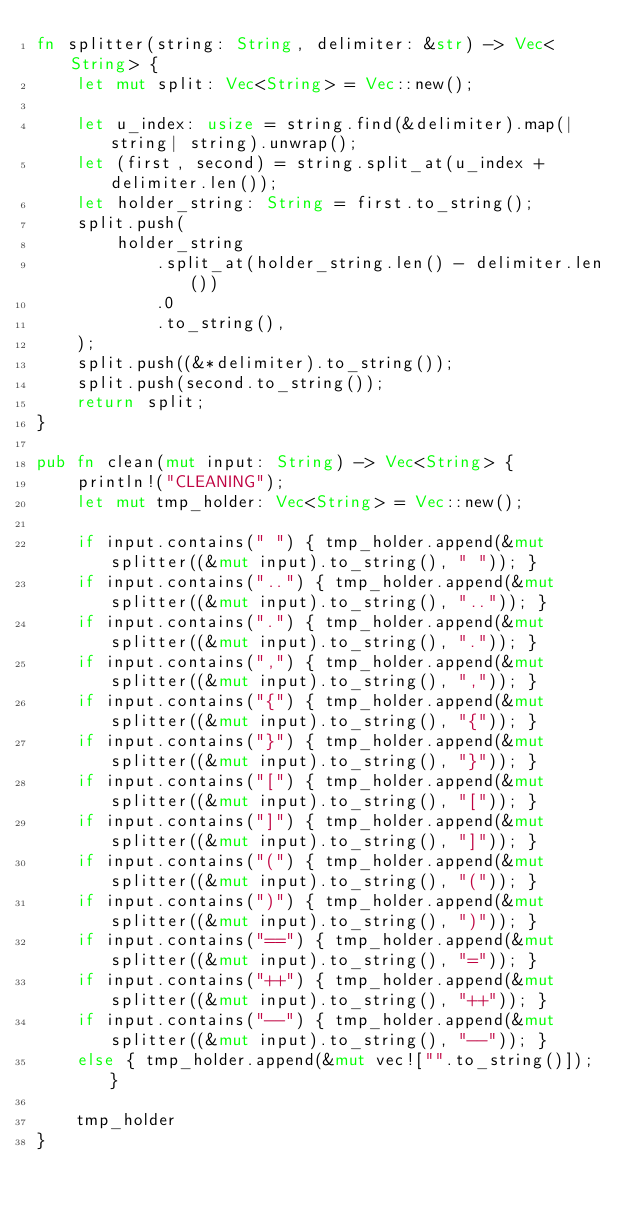Convert code to text. <code><loc_0><loc_0><loc_500><loc_500><_Rust_>fn splitter(string: String, delimiter: &str) -> Vec<String> {
    let mut split: Vec<String> = Vec::new();

    let u_index: usize = string.find(&delimiter).map(|string| string).unwrap();
    let (first, second) = string.split_at(u_index + delimiter.len());
    let holder_string: String = first.to_string();
    split.push(
        holder_string
            .split_at(holder_string.len() - delimiter.len())
            .0
            .to_string(),
    );
    split.push((&*delimiter).to_string());
    split.push(second.to_string());
    return split;
}

pub fn clean(mut input: String) -> Vec<String> {
    println!("CLEANING");
    let mut tmp_holder: Vec<String> = Vec::new();

    if input.contains(" ") { tmp_holder.append(&mut splitter((&mut input).to_string(), " ")); } 
    if input.contains("..") { tmp_holder.append(&mut splitter((&mut input).to_string(), "..")); } 
    if input.contains(".") { tmp_holder.append(&mut splitter((&mut input).to_string(), ".")); } 
    if input.contains(",") { tmp_holder.append(&mut splitter((&mut input).to_string(), ",")); } 
    if input.contains("{") { tmp_holder.append(&mut splitter((&mut input).to_string(), "{")); } 
    if input.contains("}") { tmp_holder.append(&mut splitter((&mut input).to_string(), "}")); } 
    if input.contains("[") { tmp_holder.append(&mut splitter((&mut input).to_string(), "[")); } 
    if input.contains("]") { tmp_holder.append(&mut splitter((&mut input).to_string(), "]")); } 
    if input.contains("(") { tmp_holder.append(&mut splitter((&mut input).to_string(), "(")); } 
    if input.contains(")") { tmp_holder.append(&mut splitter((&mut input).to_string(), ")")); } 
    if input.contains("==") { tmp_holder.append(&mut splitter((&mut input).to_string(), "=")); } 
    if input.contains("++") { tmp_holder.append(&mut splitter((&mut input).to_string(), "++")); } 
    if input.contains("--") { tmp_holder.append(&mut splitter((&mut input).to_string(), "--")); } 
    else { tmp_holder.append(&mut vec!["".to_string()]); }

    tmp_holder
}</code> 